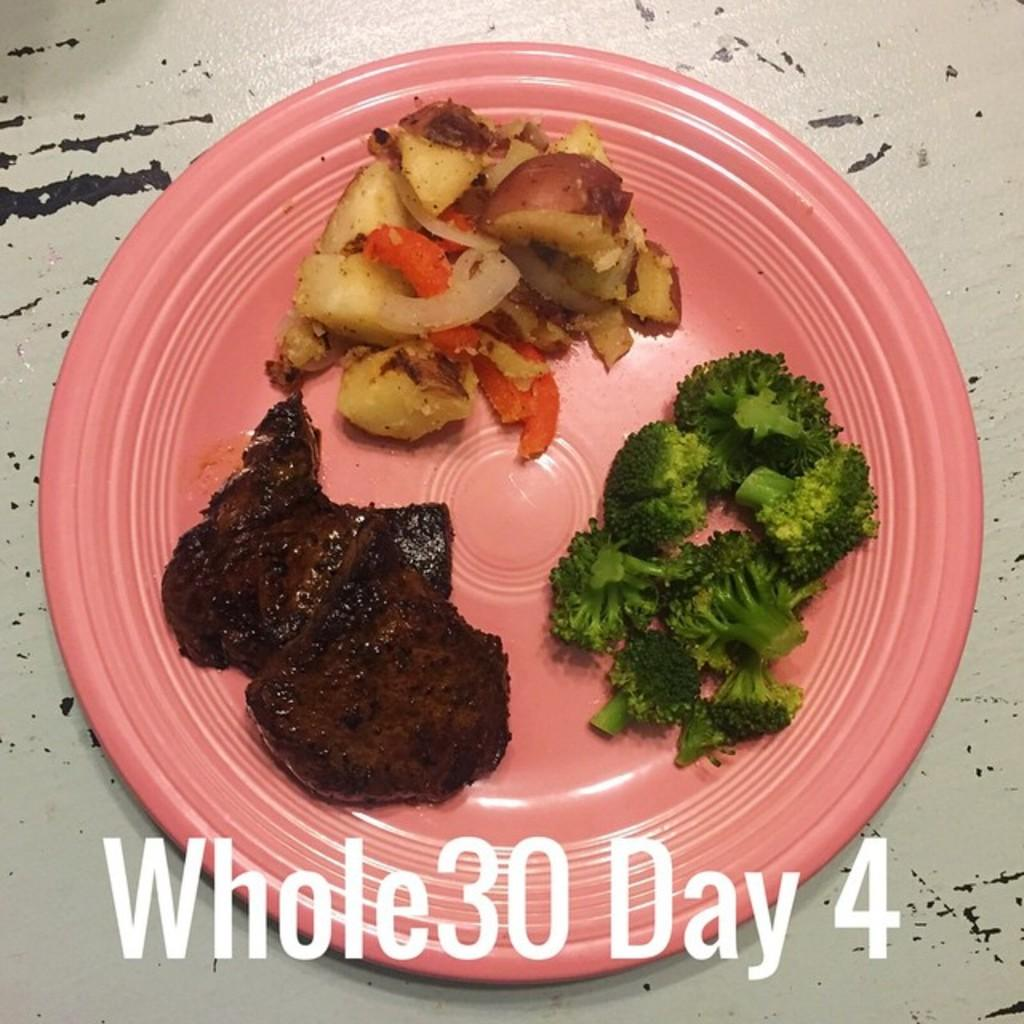What is the main food item on the plate in the image? There is a food item on a plate in the image, and it contains broccoli. Can you describe the other food item in the image? There is another food item in the image, and it is brown in color. What type of cat can be seen playing with a silver machine in the image? There is no cat or silver machine present in the image; it only features food items on a plate and beside the plate. 